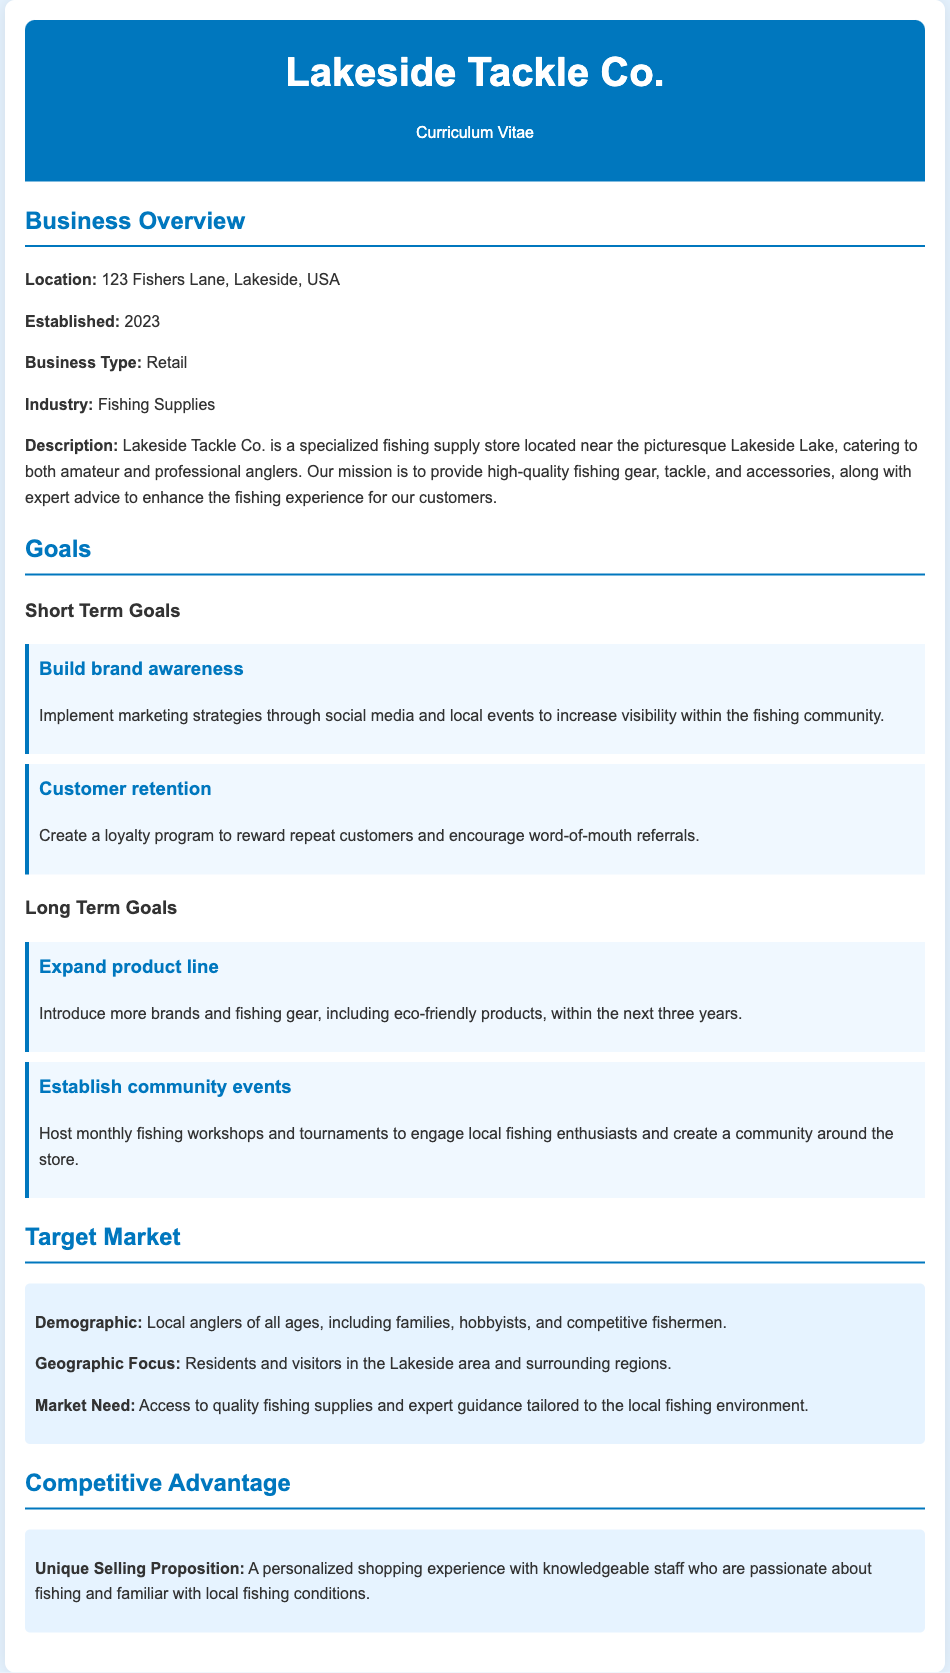what is the business type? The business type is defined in the document under the business overview section.
Answer: Retail where is Lakeside Tackle Co. located? The location is explicitly mentioned in the document.
Answer: 123 Fishers Lane, Lakeside, USA when was Lakeside Tackle Co. established? The establishment year is provided in the business overview section.
Answer: 2023 what is a short term goal of the business? The document lists several short term goals in the goals section.
Answer: Build brand awareness what is the target market demographic? The demographic information is summarized in the target market section.
Answer: Local anglers of all ages what is a long term goal of Lakeside Tackle Co.? The document outlines several long term goals in the goals section.
Answer: Expand product line what is the unique selling proposition? The document describes the competitive advantage, which includes the unique selling proposition.
Answer: A personalized shopping experience what marketing strategies will be used to increase visibility? The document specifies marketing strategies aimed at brand awareness.
Answer: Social media and local events how often will community events be hosted? The frequency of the community events is mentioned in the goals section.
Answer: Monthly 